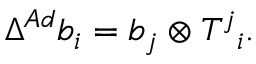<formula> <loc_0><loc_0><loc_500><loc_500>\Delta ^ { A d } b _ { i } = b _ { j } \otimes T ^ { j _ { i } .</formula> 